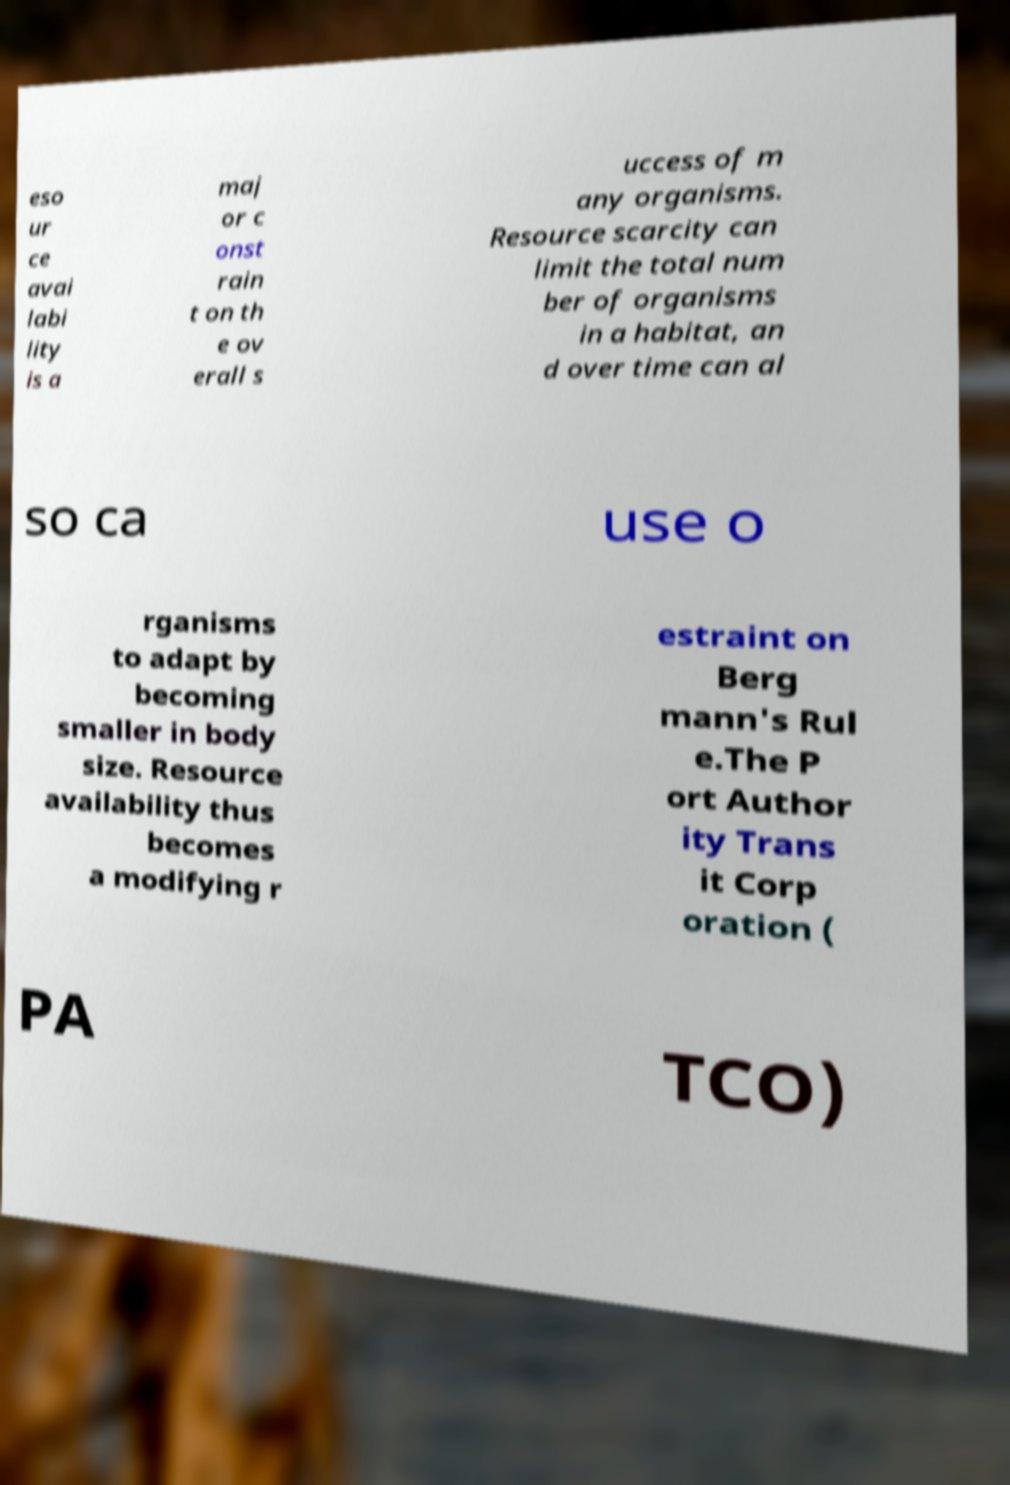Could you extract and type out the text from this image? eso ur ce avai labi lity is a maj or c onst rain t on th e ov erall s uccess of m any organisms. Resource scarcity can limit the total num ber of organisms in a habitat, an d over time can al so ca use o rganisms to adapt by becoming smaller in body size. Resource availability thus becomes a modifying r estraint on Berg mann's Rul e.The P ort Author ity Trans it Corp oration ( PA TCO) 